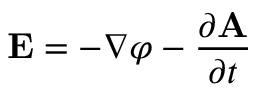<formula> <loc_0><loc_0><loc_500><loc_500>E = - \nabla \varphi - { \frac { \partial A } { \partial t } }</formula> 